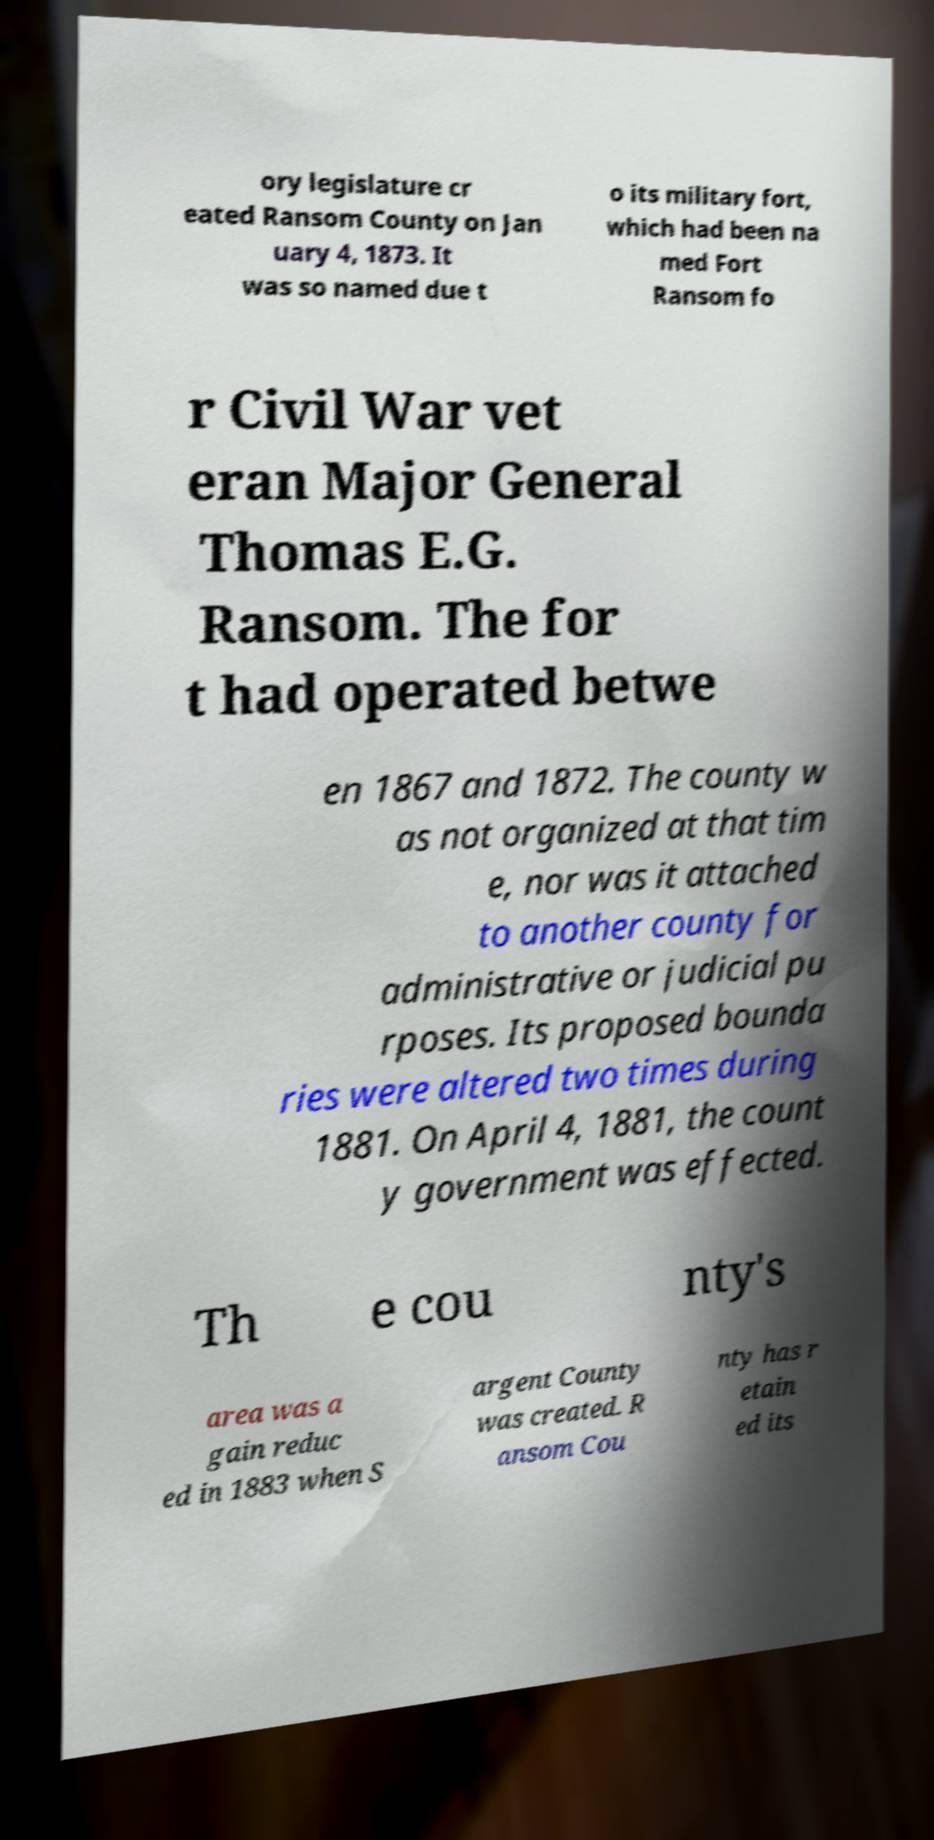Please read and relay the text visible in this image. What does it say? ory legislature cr eated Ransom County on Jan uary 4, 1873. It was so named due t o its military fort, which had been na med Fort Ransom fo r Civil War vet eran Major General Thomas E.G. Ransom. The for t had operated betwe en 1867 and 1872. The county w as not organized at that tim e, nor was it attached to another county for administrative or judicial pu rposes. Its proposed bounda ries were altered two times during 1881. On April 4, 1881, the count y government was effected. Th e cou nty's area was a gain reduc ed in 1883 when S argent County was created. R ansom Cou nty has r etain ed its 